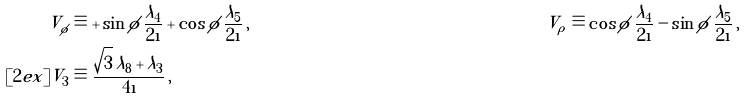<formula> <loc_0><loc_0><loc_500><loc_500>V _ { \phi } & \equiv + \sin \phi \, \frac { \lambda _ { 4 } } { 2 \i } + \cos \phi \, \frac { \lambda _ { 5 } } { 2 \i } \, , & V _ { \rho } & \equiv \cos \phi \, \frac { \lambda _ { 4 } } { 2 \i } - \sin \phi \, \frac { \lambda _ { 5 } } { 2 \i } \, , \\ [ 2 e x ] V _ { 3 } & \equiv \frac { \sqrt { 3 } \, \lambda _ { 8 } + \lambda _ { 3 } } { 4 \i } \, ,</formula> 